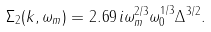Convert formula to latex. <formula><loc_0><loc_0><loc_500><loc_500>\Sigma _ { 2 } ( k , \omega _ { m } ) = 2 . 6 9 \, i \omega _ { m } ^ { 2 / 3 } \omega _ { 0 } ^ { 1 / 3 } \Delta ^ { 3 / 2 } .</formula> 